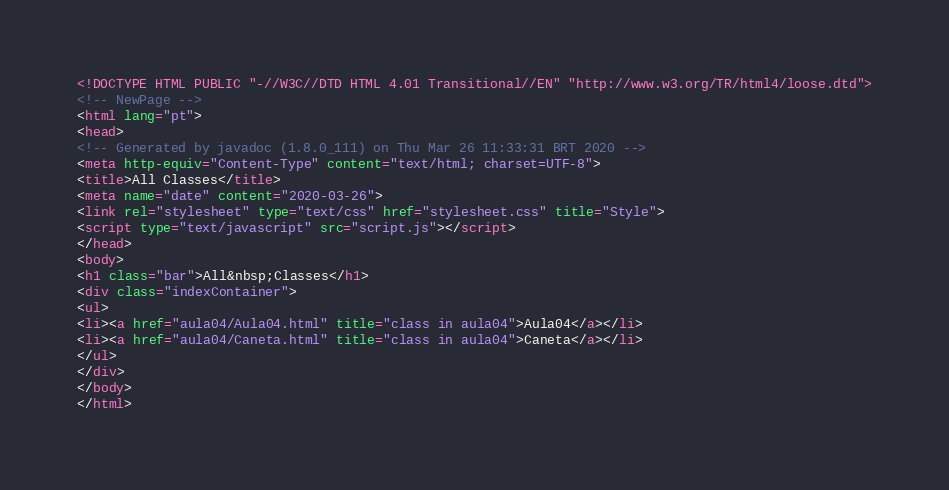<code> <loc_0><loc_0><loc_500><loc_500><_HTML_><!DOCTYPE HTML PUBLIC "-//W3C//DTD HTML 4.01 Transitional//EN" "http://www.w3.org/TR/html4/loose.dtd">
<!-- NewPage -->
<html lang="pt">
<head>
<!-- Generated by javadoc (1.8.0_111) on Thu Mar 26 11:33:31 BRT 2020 -->
<meta http-equiv="Content-Type" content="text/html; charset=UTF-8">
<title>All Classes</title>
<meta name="date" content="2020-03-26">
<link rel="stylesheet" type="text/css" href="stylesheet.css" title="Style">
<script type="text/javascript" src="script.js"></script>
</head>
<body>
<h1 class="bar">All&nbsp;Classes</h1>
<div class="indexContainer">
<ul>
<li><a href="aula04/Aula04.html" title="class in aula04">Aula04</a></li>
<li><a href="aula04/Caneta.html" title="class in aula04">Caneta</a></li>
</ul>
</div>
</body>
</html>
</code> 